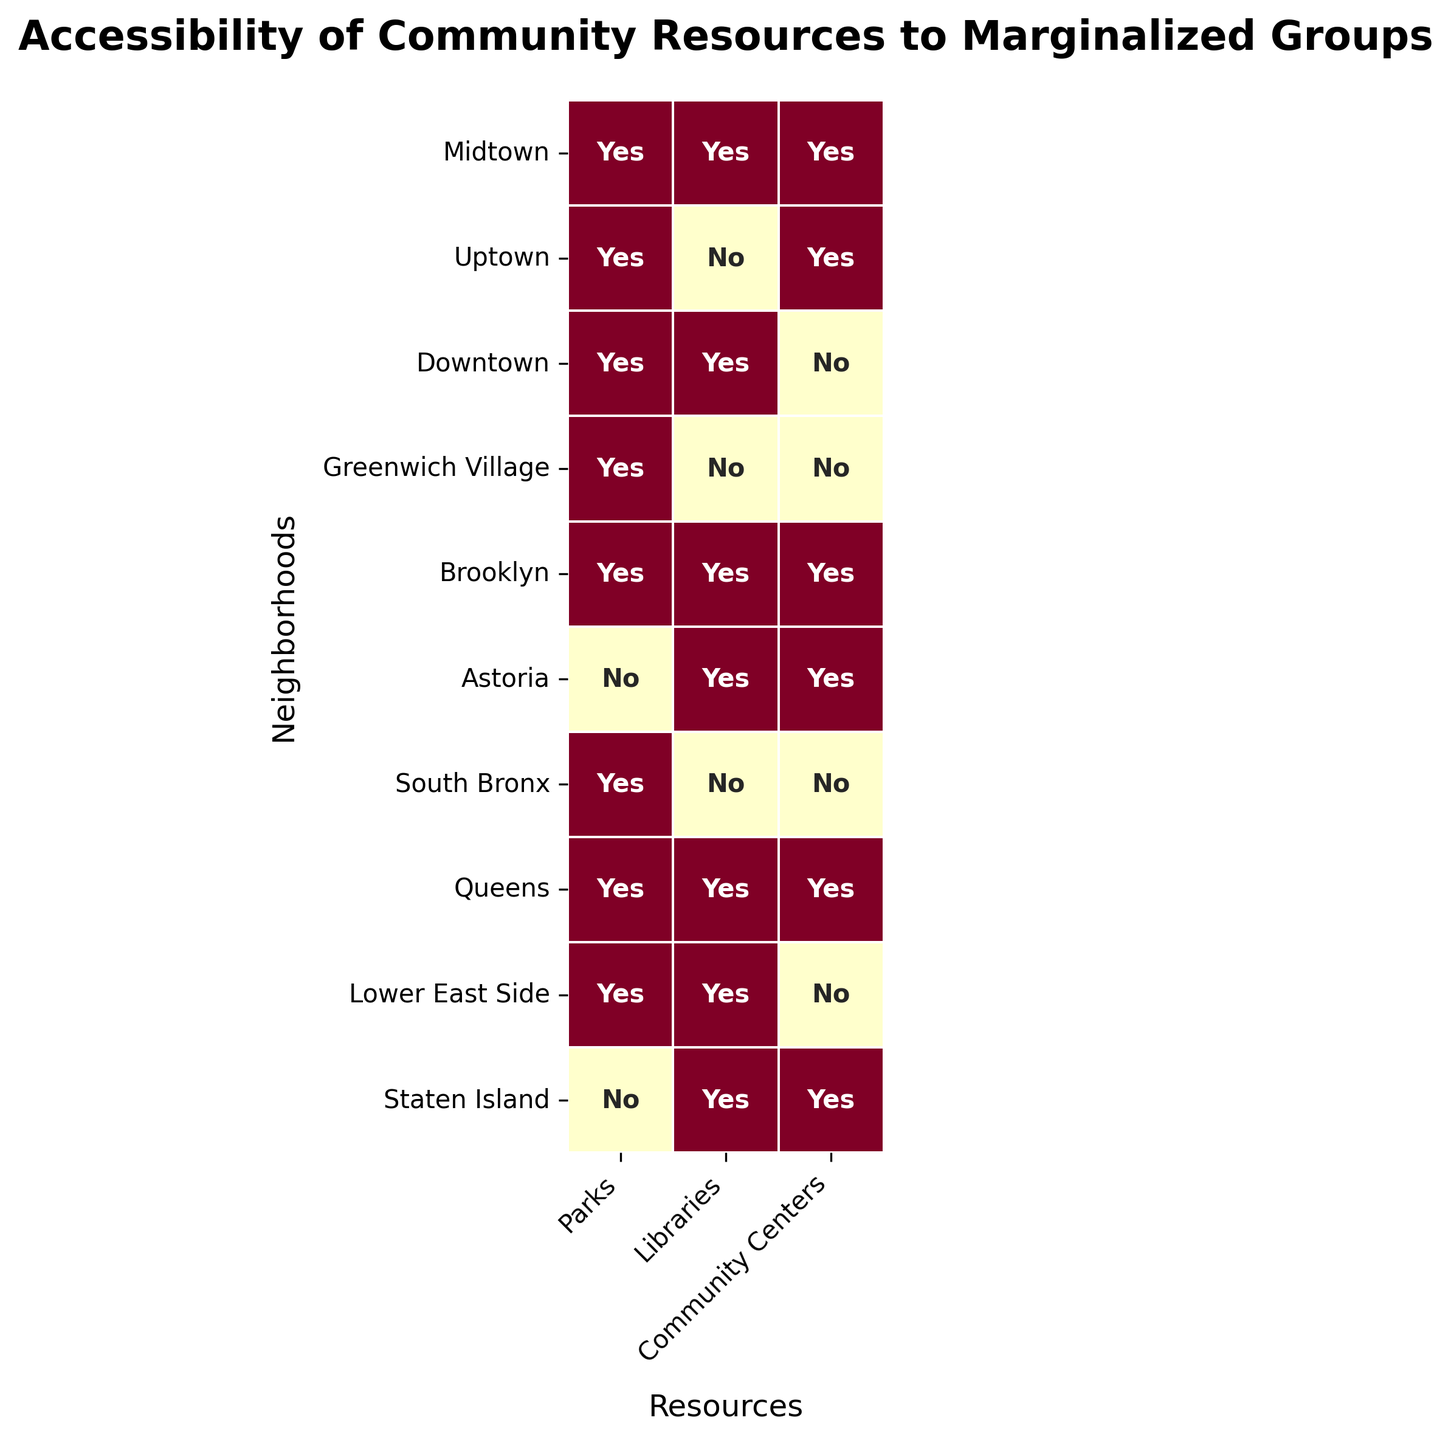What's the title of the figure? The title of the figure can be found at the top center of the heatmap. It is usually in a larger and bolder font compared to other texts.
Answer: Accessibility of Community Resources to Marginalized Groups Which neighborhood has the least accessible libraries to marginalized groups? By scanning down the library column, we look for the neighborhood rows with a "No" which indicates less accessibility. Several neighborhoods have "No," but Uptown is the first one we see.
Answer: Uptown How many neighborhoods have all three resources accessible to marginalized groups? To determine this, locate the rows where all three columns (Parks, Libraries, Community Centers) have "Yes." There are three such rows: Midtown, Brooklyn, and Queens.
Answer: Three Which resource is least accessible across all neighborhoods? Count the number of "Yes" and "No" values for each resource column. The Community Centers column has the most "No" values.
Answer: Community Centers Between Uptown and Brooklyn, which neighborhood has more accessible community resources to marginalized groups? Compare the "Yes" values in Uptown and Brooklyn rows. Brooklyn has all three resources accessible, while Uptown has only two.
Answer: Brooklyn Are there any neighborhoods where none of the resources are accessible to marginalized groups? Check each row to see if there is any neighborhood with all "No" values in all three columns. No such row exists.
Answer: No How many neighborhoods do not have accessible parks to marginalized groups? Check the Parks column and count how many rows have "No". There are two neighborhoods: Astoria and Staten Island.
Answer: Two Which neighborhood has the highest number of inaccessible resources? Count the number of "No" values in each neighborhood row. Staten Island has two "No" values (Parks and Community Centers).
Answer: Staten Island Is the accessibility of community centers higher in Downtown or Lower East Side? Compare the accessibility of Community Centers column for both neighborhoods. Downtown has "No" while Lower East Side also has "No," so they are equal.
Answer: Equal How many neighborhoods have accessible parks and libraries but not community centers? Run through the rows where Parks and Libraries columns have "Yes," and the Community Centers column has "No." There are three such neighborhoods: Downtown, Greenwich Village, and Lower East Side.
Answer: Three 